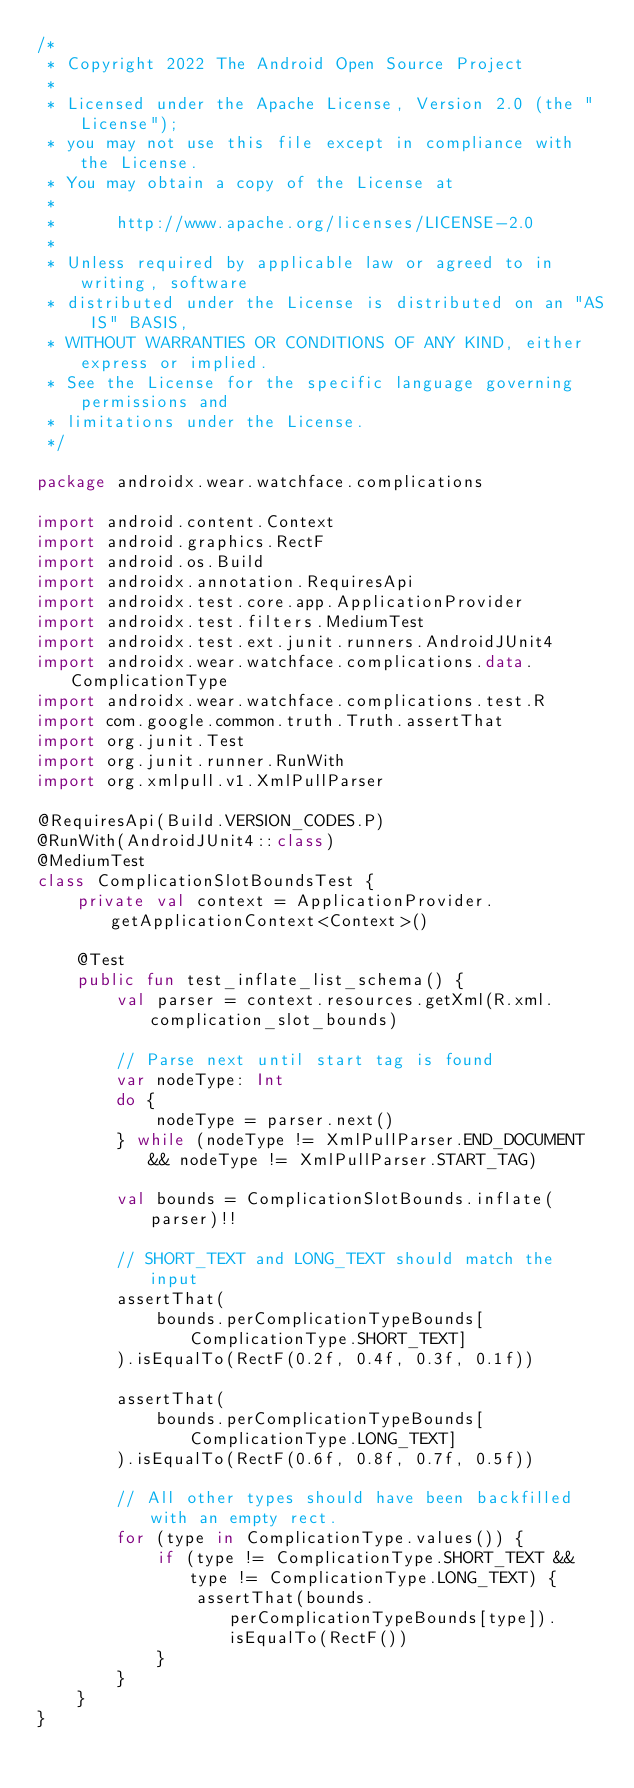<code> <loc_0><loc_0><loc_500><loc_500><_Kotlin_>/*
 * Copyright 2022 The Android Open Source Project
 *
 * Licensed under the Apache License, Version 2.0 (the "License");
 * you may not use this file except in compliance with the License.
 * You may obtain a copy of the License at
 *
 *      http://www.apache.org/licenses/LICENSE-2.0
 *
 * Unless required by applicable law or agreed to in writing, software
 * distributed under the License is distributed on an "AS IS" BASIS,
 * WITHOUT WARRANTIES OR CONDITIONS OF ANY KIND, either express or implied.
 * See the License for the specific language governing permissions and
 * limitations under the License.
 */

package androidx.wear.watchface.complications

import android.content.Context
import android.graphics.RectF
import android.os.Build
import androidx.annotation.RequiresApi
import androidx.test.core.app.ApplicationProvider
import androidx.test.filters.MediumTest
import androidx.test.ext.junit.runners.AndroidJUnit4
import androidx.wear.watchface.complications.data.ComplicationType
import androidx.wear.watchface.complications.test.R
import com.google.common.truth.Truth.assertThat
import org.junit.Test
import org.junit.runner.RunWith
import org.xmlpull.v1.XmlPullParser

@RequiresApi(Build.VERSION_CODES.P)
@RunWith(AndroidJUnit4::class)
@MediumTest
class ComplicationSlotBoundsTest {
    private val context = ApplicationProvider.getApplicationContext<Context>()

    @Test
    public fun test_inflate_list_schema() {
        val parser = context.resources.getXml(R.xml.complication_slot_bounds)

        // Parse next until start tag is found
        var nodeType: Int
        do {
            nodeType = parser.next()
        } while (nodeType != XmlPullParser.END_DOCUMENT && nodeType != XmlPullParser.START_TAG)

        val bounds = ComplicationSlotBounds.inflate(parser)!!

        // SHORT_TEXT and LONG_TEXT should match the input
        assertThat(
            bounds.perComplicationTypeBounds[ComplicationType.SHORT_TEXT]
        ).isEqualTo(RectF(0.2f, 0.4f, 0.3f, 0.1f))

        assertThat(
            bounds.perComplicationTypeBounds[ComplicationType.LONG_TEXT]
        ).isEqualTo(RectF(0.6f, 0.8f, 0.7f, 0.5f))

        // All other types should have been backfilled with an empty rect.
        for (type in ComplicationType.values()) {
            if (type != ComplicationType.SHORT_TEXT && type != ComplicationType.LONG_TEXT) {
                assertThat(bounds.perComplicationTypeBounds[type]).isEqualTo(RectF())
            }
        }
    }
}</code> 